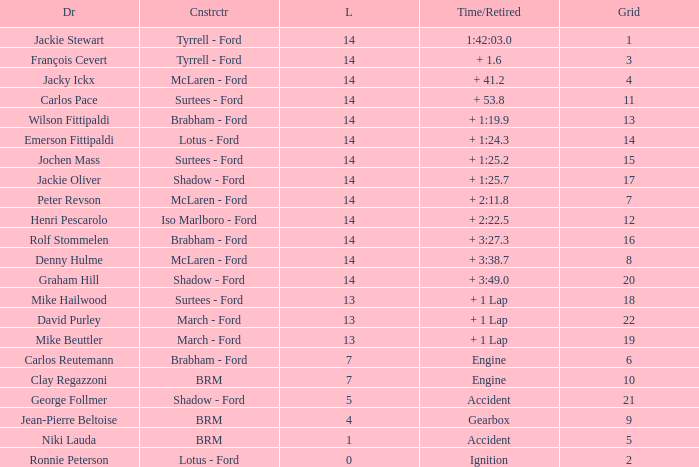What is the low lap total for henri pescarolo with a grad larger than 6? 14.0. 